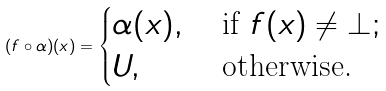Convert formula to latex. <formula><loc_0><loc_0><loc_500><loc_500>( f \circ \alpha ) ( x ) = \begin{cases} \alpha ( x ) , & \text { if } f ( x ) \neq \bot ; \\ U , & \text { otherwise.} \end{cases}</formula> 